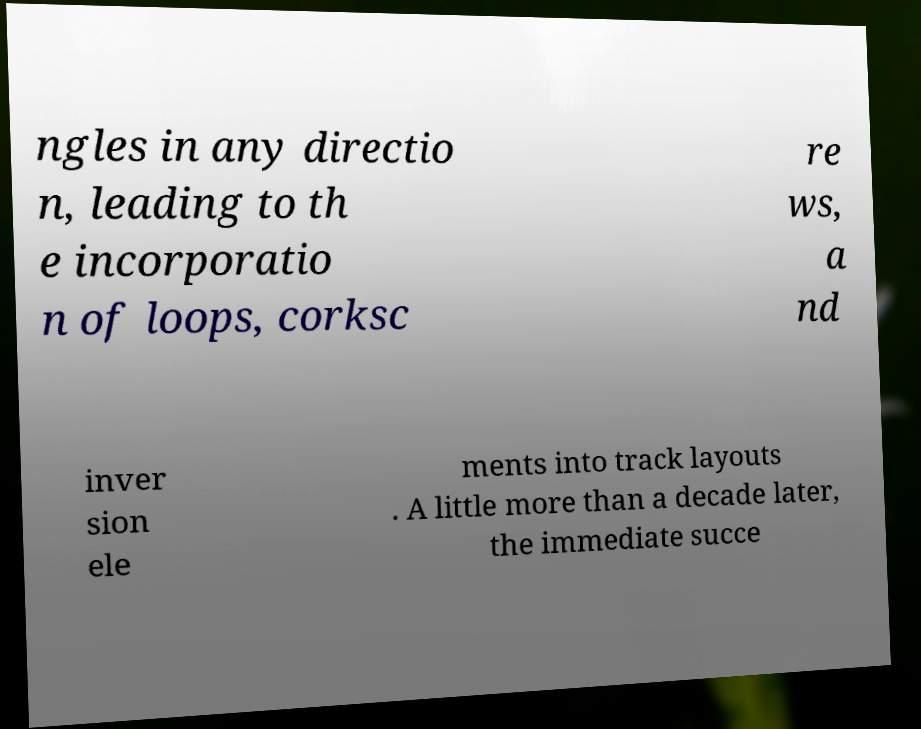Can you accurately transcribe the text from the provided image for me? ngles in any directio n, leading to th e incorporatio n of loops, corksc re ws, a nd inver sion ele ments into track layouts . A little more than a decade later, the immediate succe 